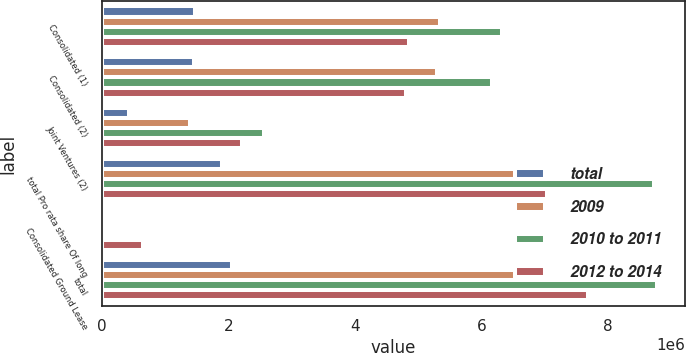Convert chart to OTSL. <chart><loc_0><loc_0><loc_500><loc_500><stacked_bar_chart><ecel><fcel>Consolidated (1)<fcel>Consolidated (2)<fcel>Joint Ventures (2)<fcel>total Pro rata share Of long<fcel>Consolidated Ground Lease<fcel>total<nl><fcel>total<fcel>1.47551e+06<fcel>1.46487e+06<fcel>437040<fcel>1.90191e+06<fcel>16530<fcel>2.06048e+06<nl><fcel>2009<fcel>5.35225e+06<fcel>5.30435e+06<fcel>1.39166e+06<fcel>6.69601e+06<fcel>32626<fcel>6.77823e+06<nl><fcel>2010 to 2011<fcel>6.33377e+06<fcel>6.16478e+06<fcel>2.56896e+06<fcel>8.73374e+06<fcel>49821<fcel>8.78356e+06<nl><fcel>2012 to 2014<fcel>4.8638e+06<fcel>4.81564e+06<fcel>2.22363e+06<fcel>7.03927e+06<fcel>653052<fcel>7.69232e+06<nl></chart> 